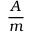<formula> <loc_0><loc_0><loc_500><loc_500>\frac { A } { m }</formula> 